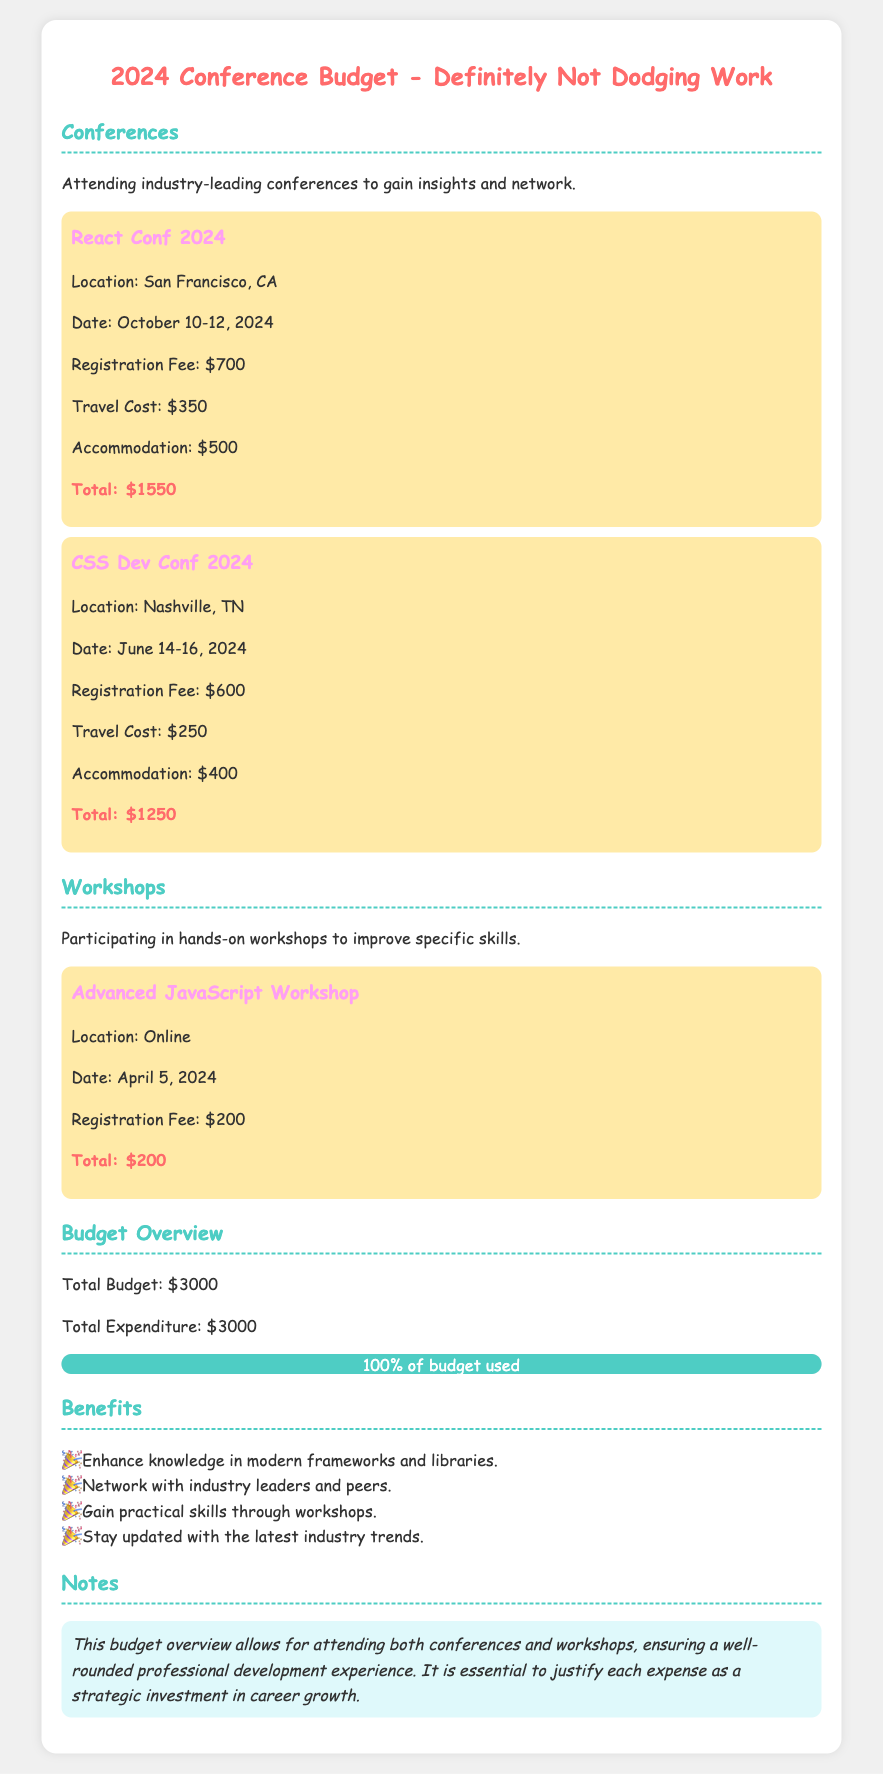what is the total budget? The total budget is explicitly stated in the document under the budget overview section.
Answer: $3000 what is the registration fee for React Conf 2024? The registration fee for React Conf 2024 can be found in the event details section for this conference.
Answer: $700 what is the location of CSS Dev Conf 2024? The location of CSS Dev Conf 2024 is mentioned in the event details section for this conference.
Answer: Nashville, TN how much was spent on the Advanced JavaScript Workshop? The total expenditure for the Advanced JavaScript Workshop is identified in the event details for this workshop.
Answer: $200 how much did the total expenditure equal? The total expenditure is found in the budget overview section, which shows it is equal to the budget.
Answer: $3000 which city will the React Conf 2024 take place in? The city for React Conf 2024 is included in the event information for that conference.
Answer: San Francisco, CA how many conferences are listed in the document? Count the number of events categorized under conferences to find this information.
Answer: 2 what percentage of the budget was used? The document states this percentage in the progress section of the budget overview.
Answer: 100% what is one benefit mentioned in the benefits section? The benefits section lists multiple benefits; any single one can be answered based on textual details.
Answer: Enhance knowledge in modern frameworks and libraries 